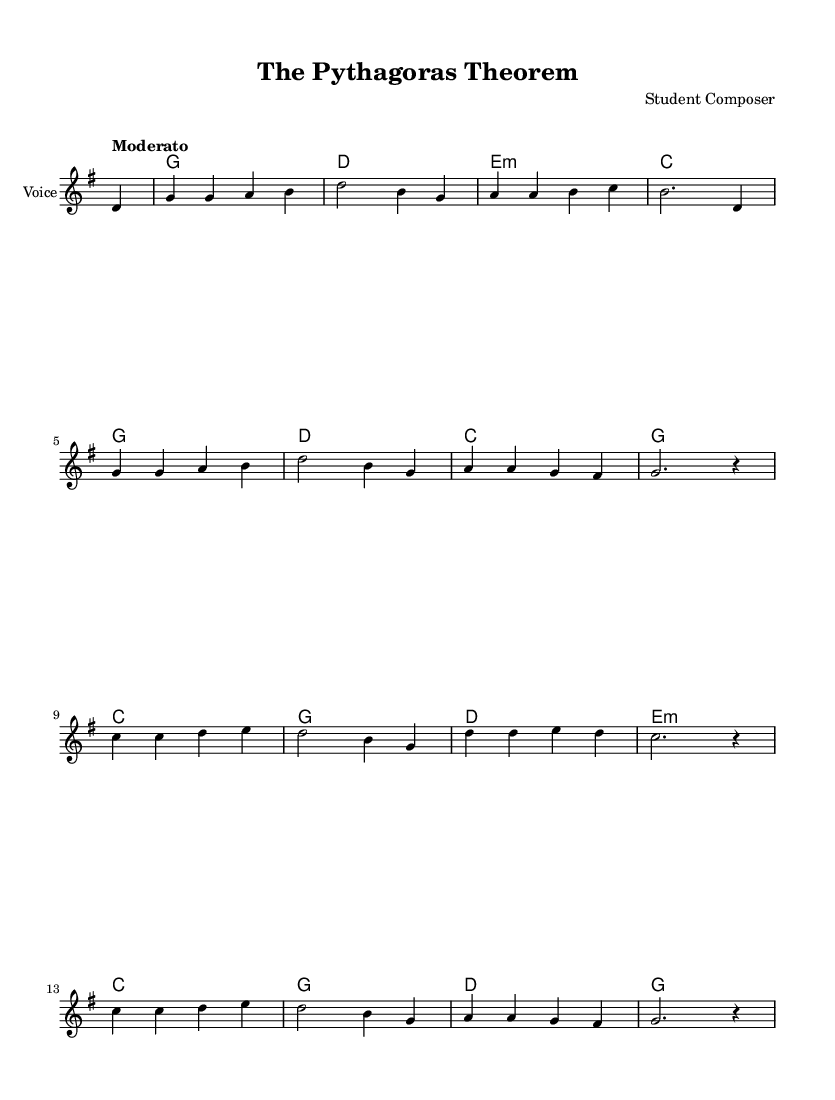What is the key signature of this music? The key signature is G major, which has one sharp (F#). This can be identified by looking at the key signature symbol at the beginning of the staff.
Answer: G major What is the time signature of this music? The time signature is 4/4, which is indicated at the beginning of the piece. This means there are four beats in each measure, and the quarter note gets one beat.
Answer: 4/4 What is the tempo marking of this music? The tempo marking is "Moderato," which indicates a moderate speed. This can be found in the tempo indication that appears at the beginning of the score.
Answer: Moderato Which mathematician does this ballad describe? The ballad describes Pythagoras, as stated in the lyrics of the piece. The lyrics mention his name and reference his contributions to mathematics.
Answer: Pythagoras How many lines are in the lyrics of this ballad? The lyrics consist of eight lines as indicated by the number of lyric phrases provided in the lyric section. Counting each line separated by spaces confirms that there are eight distinct lines.
Answer: Eight What mathematical theorem is referenced in the lyrics? The lyrics reference the Pythagorean theorem, as highlighted in the lines discussing the relationship A squared plus B squared equals C squared.
Answer: Pythagorean theorem What type of music is this piece classified as? This piece is classified as a Folk ballad, which is indicated by its storytelling nature and the subject matter of a historical mathematician. The lyrical format and simplicity of the melody are typical of Folk music.
Answer: Folk ballad 